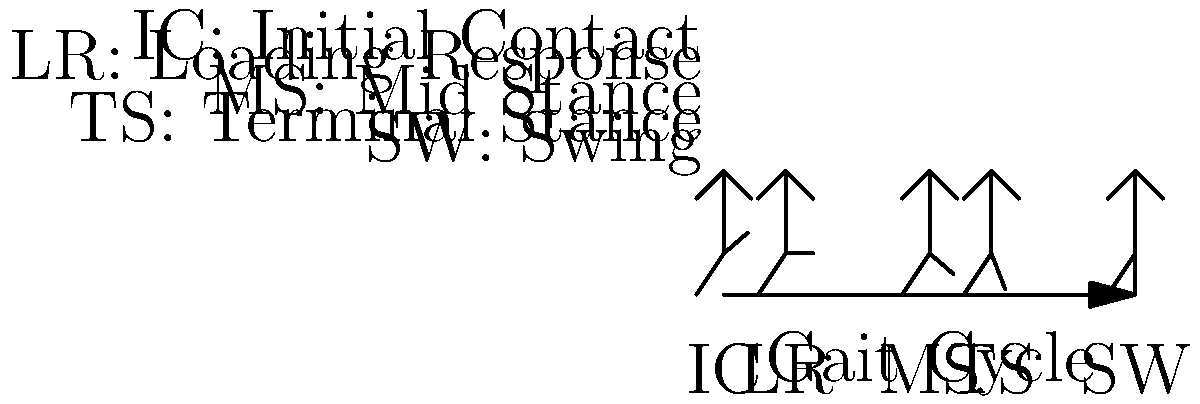In the stick figure diagram of a child's gait cycle, which phase demonstrates the greatest potential for energy storage in the Achilles tendon, and why is this important for efficient locomotion? To answer this question, let's break down the gait cycle and consider the biomechanics of each phase:

1. Initial Contact (IC): The heel strikes the ground, but there's minimal energy storage in the Achilles tendon.

2. Loading Response (LR): Weight is transferred onto the limb, but the Achilles tendon is not yet significantly stretched.

3. Mid Stance (MS): The body's center of mass passes over the supporting foot. The Achilles tendon begins to stretch as the ankle dorsiflexes.

4. Terminal Stance (TS): This is the key phase for energy storage. As the heel rises and the ankle continues to dorsiflex, the Achilles tendon is maximally stretched. This stretch stores elastic energy in the tendon.

5. Swing (SW): The stored energy is released as the foot pushes off, helping to propel the body forward.

The Terminal Stance phase demonstrates the greatest potential for energy storage in the Achilles tendon. This is important for efficient locomotion because:

a) Energy Conservation: The stretched tendon stores elastic energy, which is then released during push-off, reducing the muscular effort required.

b) Power Generation: The quick release of stored energy contributes to a more powerful push-off, aiding forward propulsion.

c) Metabolic Efficiency: By utilizing the tendon's elastic properties, the body reduces the metabolic cost of walking or running.

d) Smooth Transition: The stored energy helps create a smooth transition from stance to swing phase.

Understanding this principle is crucial for parents interested in their child's motor development and for designing activities that promote healthy gait patterns.
Answer: Terminal Stance phase; maximizes energy storage for efficient propulsion and reduced metabolic cost. 